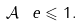Convert formula to latex. <formula><loc_0><loc_0><loc_500><loc_500>\| \mathcal { A } _ { \ } e \| \leqslant 1 .</formula> 